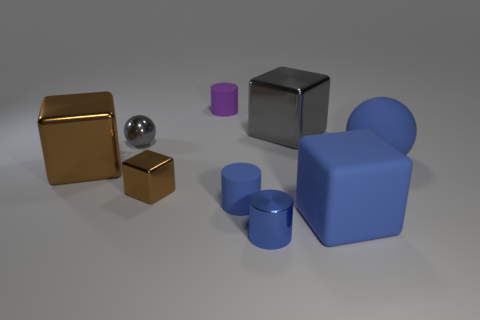The blue object that is made of the same material as the big gray thing is what shape?
Offer a very short reply. Cylinder. The large block that is right of the gray metallic object that is right of the sphere that is on the left side of the tiny shiny cylinder is made of what material?
Your answer should be compact. Rubber. What number of objects are small metallic things that are in front of the tiny gray metallic ball or blue cubes?
Your answer should be very brief. 3. What number of other things are the same shape as the large gray metal thing?
Offer a terse response. 3. Is the number of tiny things in front of the small blue rubber cylinder greater than the number of big blue matte cubes?
Ensure brevity in your answer.  No. There is another thing that is the same shape as the small gray metallic object; what size is it?
Offer a very short reply. Large. Is there any other thing that has the same material as the small gray object?
Offer a very short reply. Yes. The large gray metallic object has what shape?
Provide a succinct answer. Cube. What is the shape of the brown object that is the same size as the purple rubber thing?
Your answer should be very brief. Cube. Is there anything else that is the same color as the small metallic cylinder?
Provide a succinct answer. Yes. 